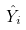Convert formula to latex. <formula><loc_0><loc_0><loc_500><loc_500>\hat { Y } _ { i }</formula> 